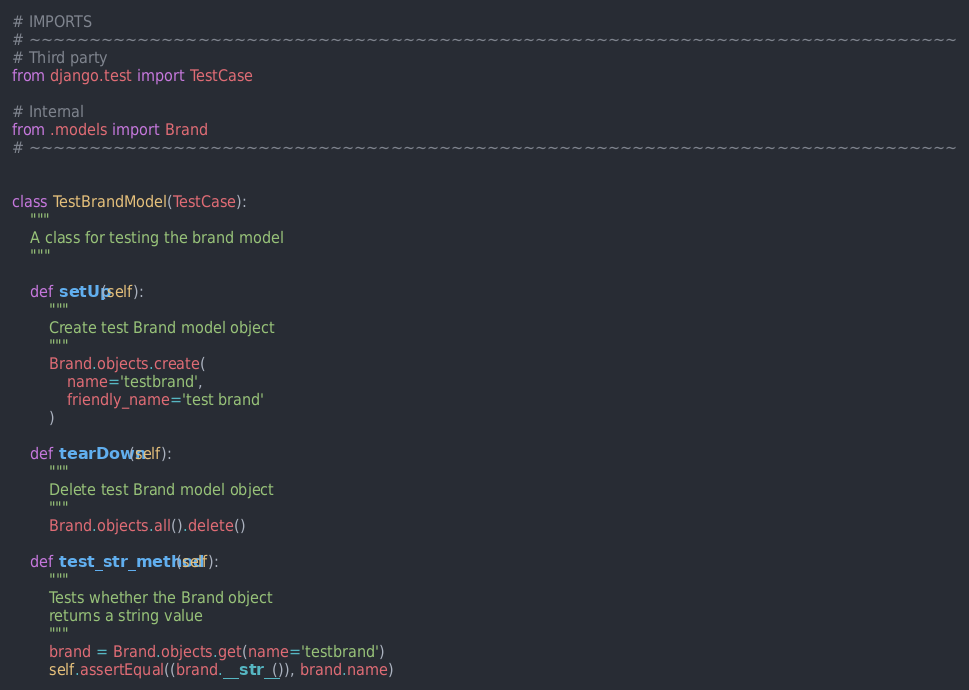Convert code to text. <code><loc_0><loc_0><loc_500><loc_500><_Python_># IMPORTS
# ~~~~~~~~~~~~~~~~~~~~~~~~~~~~~~~~~~~~~~~~~~~~~~~~~~~~~~~~~~~~~~~~~~~~~~~~~~~~~
# Third party
from django.test import TestCase

# Internal
from .models import Brand
# ~~~~~~~~~~~~~~~~~~~~~~~~~~~~~~~~~~~~~~~~~~~~~~~~~~~~~~~~~~~~~~~~~~~~~~~~~~~~~


class TestBrandModel(TestCase):
    """
    A class for testing the brand model
    """

    def setUp(self):
        """
        Create test Brand model object
        """
        Brand.objects.create(
            name='testbrand',
            friendly_name='test brand'
        )

    def tearDown(self):
        """
        Delete test Brand model object
        """
        Brand.objects.all().delete()

    def test_str_method(self):
        """
        Tests whether the Brand object
        returns a string value
        """
        brand = Brand.objects.get(name='testbrand')
        self.assertEqual((brand.__str__()), brand.name)
</code> 